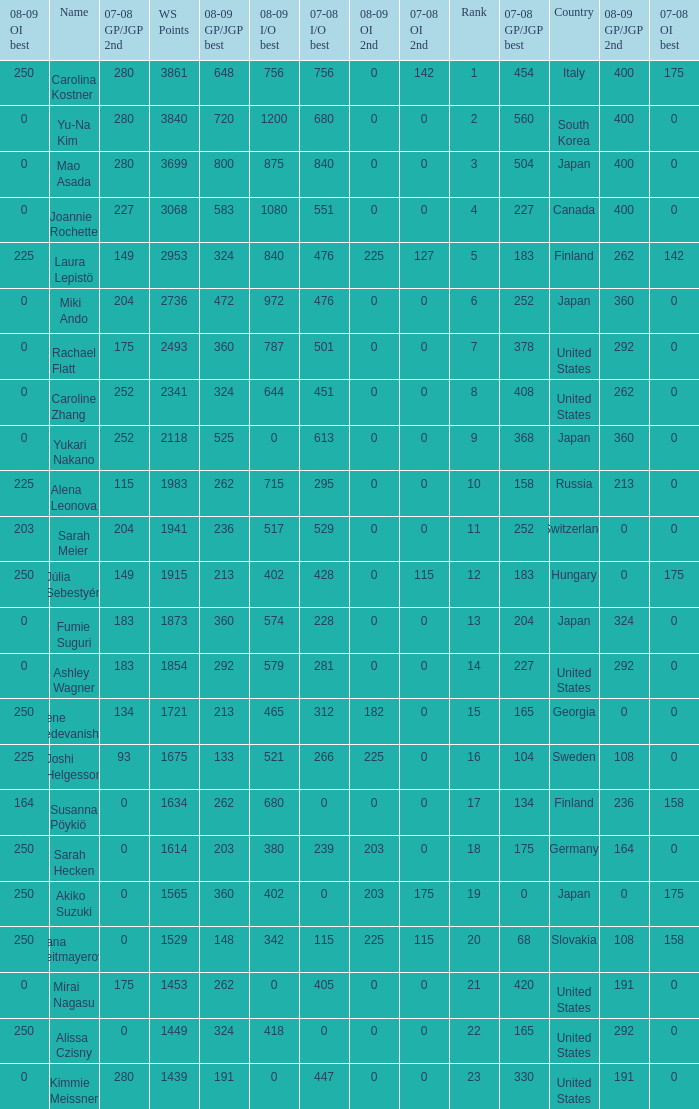Can you give me this table as a dict? {'header': ['08-09 OI best', 'Name', '07-08 GP/JGP 2nd', 'WS Points', '08-09 GP/JGP best', '08-09 I/O best', '07-08 I/O best', '08-09 OI 2nd', '07-08 OI 2nd', 'Rank', '07-08 GP/JGP best', 'Country', '08-09 GP/JGP 2nd', '07-08 OI best'], 'rows': [['250', 'Carolina Kostner', '280', '3861', '648', '756', '756', '0', '142', '1', '454', 'Italy', '400', '175'], ['0', 'Yu-Na Kim', '280', '3840', '720', '1200', '680', '0', '0', '2', '560', 'South Korea', '400', '0'], ['0', 'Mao Asada', '280', '3699', '800', '875', '840', '0', '0', '3', '504', 'Japan', '400', '0'], ['0', 'Joannie Rochette', '227', '3068', '583', '1080', '551', '0', '0', '4', '227', 'Canada', '400', '0'], ['225', 'Laura Lepistö', '149', '2953', '324', '840', '476', '225', '127', '5', '183', 'Finland', '262', '142'], ['0', 'Miki Ando', '204', '2736', '472', '972', '476', '0', '0', '6', '252', 'Japan', '360', '0'], ['0', 'Rachael Flatt', '175', '2493', '360', '787', '501', '0', '0', '7', '378', 'United States', '292', '0'], ['0', 'Caroline Zhang', '252', '2341', '324', '644', '451', '0', '0', '8', '408', 'United States', '262', '0'], ['0', 'Yukari Nakano', '252', '2118', '525', '0', '613', '0', '0', '9', '368', 'Japan', '360', '0'], ['225', 'Alena Leonova', '115', '1983', '262', '715', '295', '0', '0', '10', '158', 'Russia', '213', '0'], ['203', 'Sarah Meier', '204', '1941', '236', '517', '529', '0', '0', '11', '252', 'Switzerland', '0', '0'], ['250', 'Júlia Sebestyén', '149', '1915', '213', '402', '428', '0', '115', '12', '183', 'Hungary', '0', '175'], ['0', 'Fumie Suguri', '183', '1873', '360', '574', '228', '0', '0', '13', '204', 'Japan', '324', '0'], ['0', 'Ashley Wagner', '183', '1854', '292', '579', '281', '0', '0', '14', '227', 'United States', '292', '0'], ['250', 'Elene Gedevanishvili', '134', '1721', '213', '465', '312', '182', '0', '15', '165', 'Georgia', '0', '0'], ['225', 'Joshi Helgesson', '93', '1675', '133', '521', '266', '225', '0', '16', '104', 'Sweden', '108', '0'], ['164', 'Susanna Pöykiö', '0', '1634', '262', '680', '0', '0', '0', '17', '134', 'Finland', '236', '158'], ['250', 'Sarah Hecken', '0', '1614', '203', '380', '239', '203', '0', '18', '175', 'Germany', '164', '0'], ['250', 'Akiko Suzuki', '0', '1565', '360', '402', '0', '203', '175', '19', '0', 'Japan', '0', '175'], ['250', 'Ivana Reitmayerova', '0', '1529', '148', '342', '115', '225', '115', '20', '68', 'Slovakia', '108', '158'], ['0', 'Mirai Nagasu', '175', '1453', '262', '0', '405', '0', '0', '21', '420', 'United States', '191', '0'], ['250', 'Alissa Czisny', '0', '1449', '324', '418', '0', '0', '0', '22', '165', 'United States', '292', '0'], ['0', 'Kimmie Meissner', '280', '1439', '191', '0', '447', '0', '0', '23', '330', 'United States', '191', '0']]} 08-09 gp/jgp 2nd is 213 and ws points will be what maximum 1983.0. 